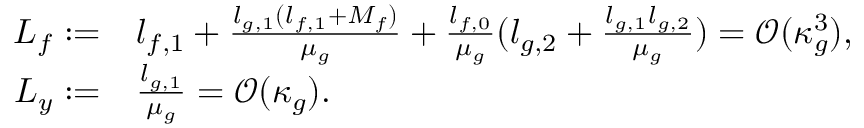<formula> <loc_0><loc_0><loc_500><loc_500>\begin{array} { r l } { L _ { f } \colon = } & { l _ { f , 1 } + \frac { l _ { g , 1 } ( l _ { f , 1 } + M _ { f } ) } { \mu _ { g } } + \frac { l _ { f , 0 } } { \mu _ { g } } ( l _ { g , 2 } + \frac { l _ { g , 1 } l _ { g , 2 } } { \mu _ { g } } ) = \mathcal { O } ( \kappa _ { g } ^ { 3 } ) , } \\ { L _ { y } \colon = } & { \frac { l _ { g , 1 } } { \mu _ { g } } = \mathcal { O } ( \kappa _ { g } ) . } \end{array}</formula> 